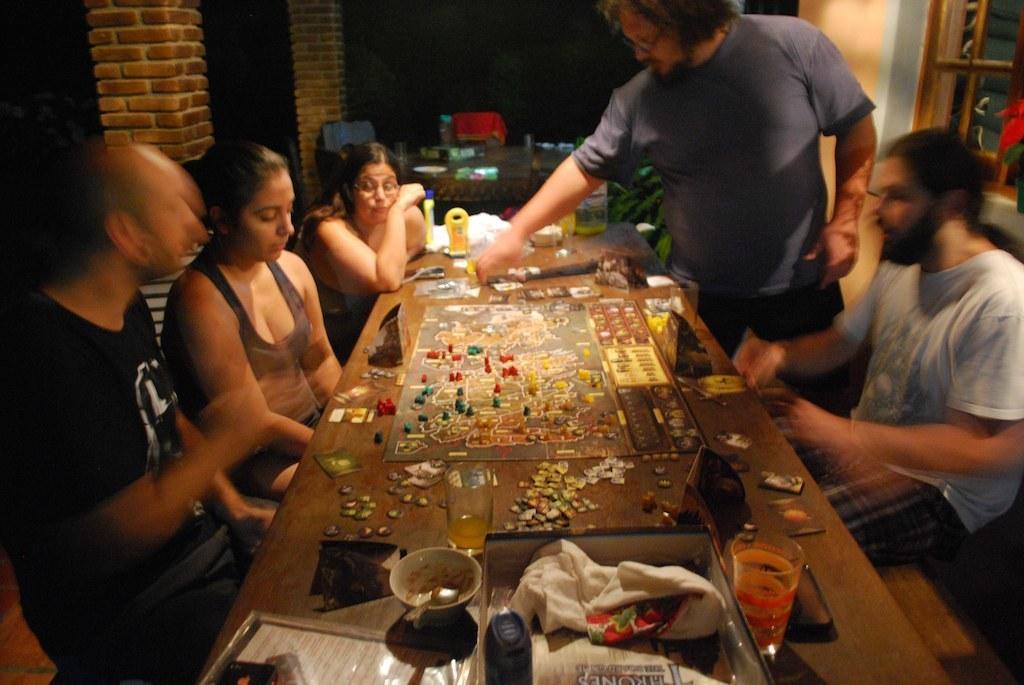Describe this image in one or two sentences. In this image on the right, there is a man, he wears a t shirt, trouser, he is sitting and there is a man, he wears a t shirt, trouser, he is standing. In the middle there is a table on that there are glasses, bowls, clothes, boxes, posters, puzzles, coins and some other items. On the left there is a man, he wears a t shirt, trouser and there are two women. In the background there are chairs, window and wall. 